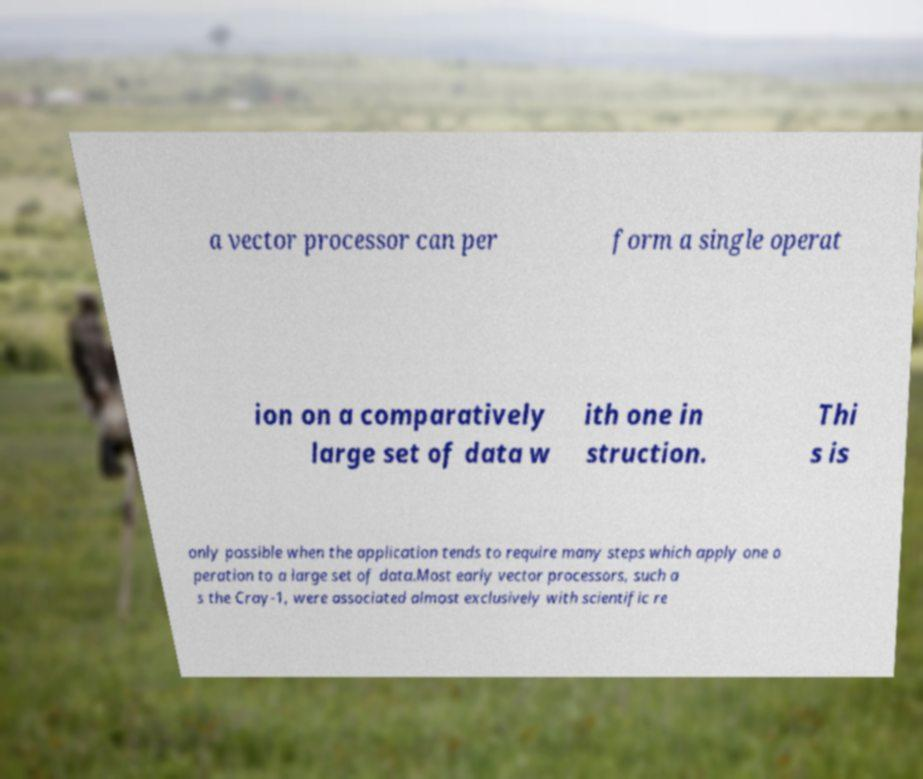What messages or text are displayed in this image? I need them in a readable, typed format. a vector processor can per form a single operat ion on a comparatively large set of data w ith one in struction. Thi s is only possible when the application tends to require many steps which apply one o peration to a large set of data.Most early vector processors, such a s the Cray-1, were associated almost exclusively with scientific re 